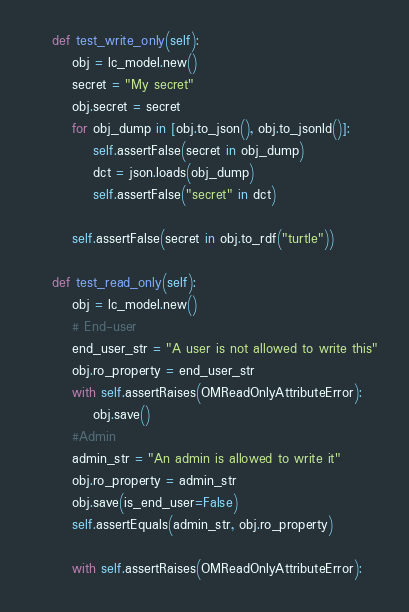Convert code to text. <code><loc_0><loc_0><loc_500><loc_500><_Python_>
    def test_write_only(self):
        obj = lc_model.new()
        secret = "My secret"
        obj.secret = secret
        for obj_dump in [obj.to_json(), obj.to_jsonld()]:
            self.assertFalse(secret in obj_dump)
            dct = json.loads(obj_dump)
            self.assertFalse("secret" in dct)

        self.assertFalse(secret in obj.to_rdf("turtle"))

    def test_read_only(self):
        obj = lc_model.new()
        # End-user
        end_user_str = "A user is not allowed to write this"
        obj.ro_property = end_user_str
        with self.assertRaises(OMReadOnlyAttributeError):
            obj.save()
        #Admin
        admin_str = "An admin is allowed to write it"
        obj.ro_property = admin_str
        obj.save(is_end_user=False)
        self.assertEquals(admin_str, obj.ro_property)

        with self.assertRaises(OMReadOnlyAttributeError):</code> 